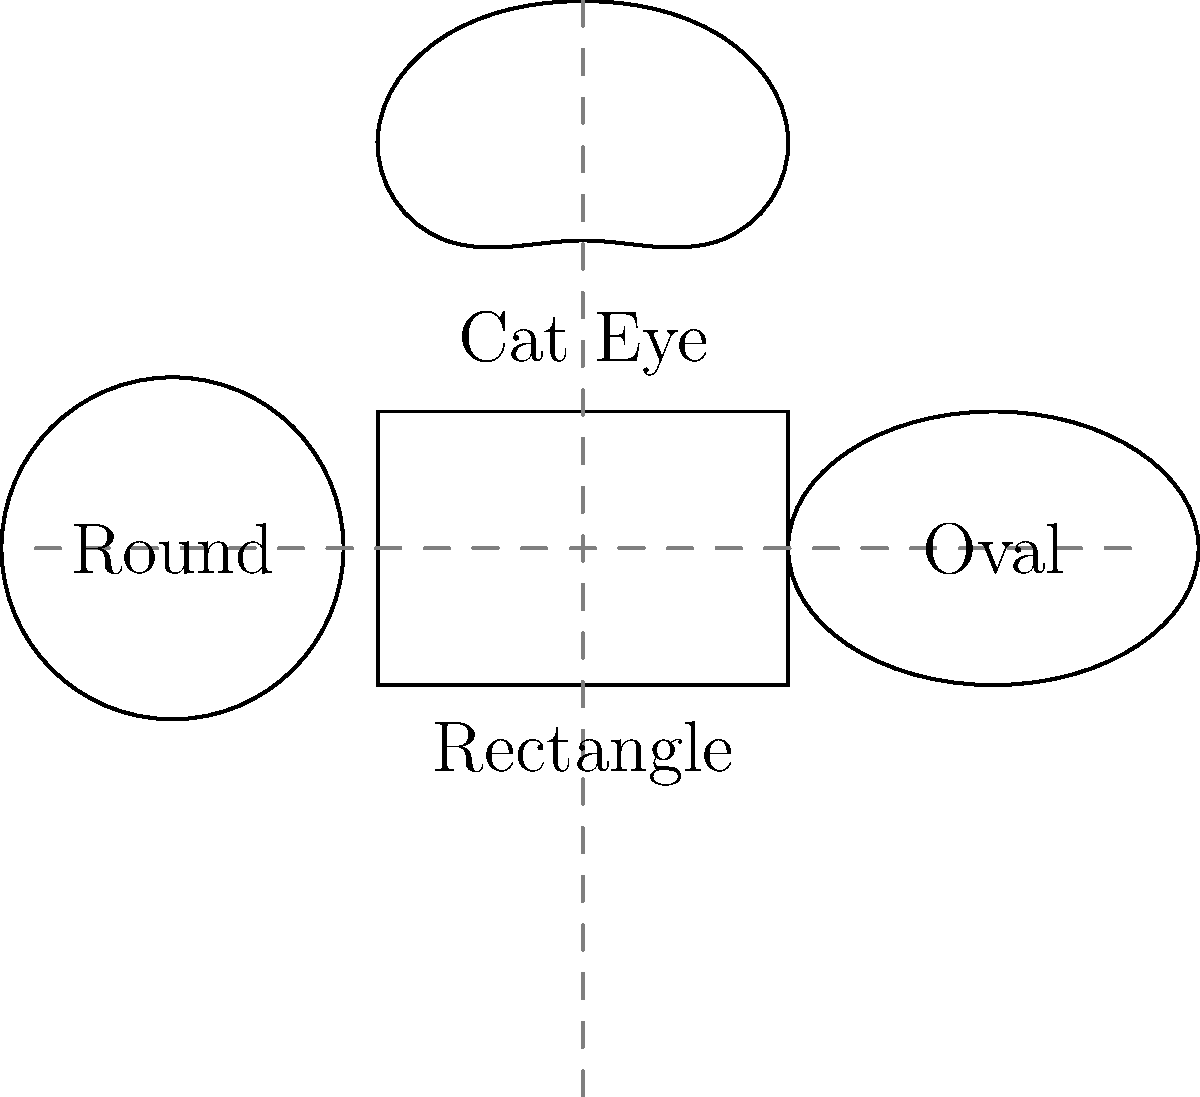As a quality control officer, you're tasked with implementing a machine learning model to classify eyewear frame shapes from front-view images. Given the diagram showing four common frame shapes (Rectangle, Oval, Cat Eye, and Round), which geometric feature would be most effective in distinguishing between Rectangle and Oval frames? To distinguish between Rectangle and Oval frames, we need to consider their geometric properties:

1. Rectangle frames:
   - Have straight sides and sharp corners
   - Aspect ratio (width to height) is typically less extreme

2. Oval frames:
   - Have curved sides with no sharp corners
   - Aspect ratio may be more pronounced (wider relative to height)

The key distinguishing feature between these shapes is the curvature of the sides. To quantify this:

3. Calculate the radius of curvature:
   - For rectangles, the radius of curvature at the sides approaches infinity
   - For ovals, the radius of curvature is finite and measurable

4. Implement curvature detection:
   - Use edge detection algorithms to identify frame boundaries
   - Apply curve fitting techniques to measure the curvature of the sides

5. Set a threshold:
   - Define a curvature threshold to classify frames as Rectangle (low curvature) or Oval (high curvature)

Therefore, the most effective geometric feature for distinguishing between Rectangle and Oval frames is the curvature of the sides.
Answer: Side curvature 